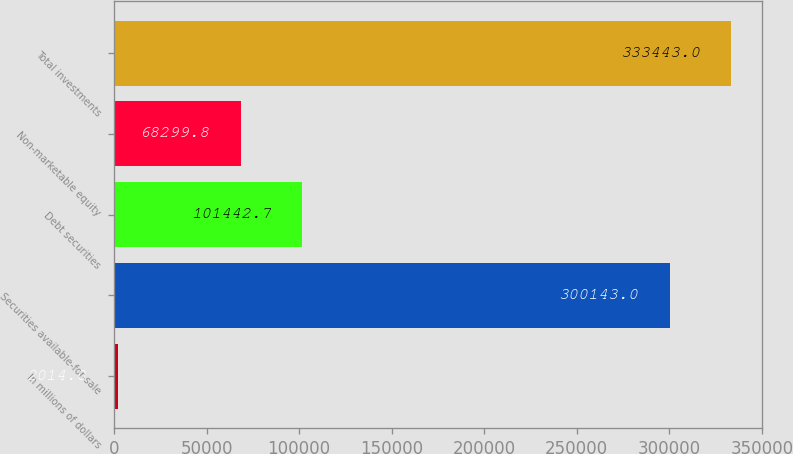<chart> <loc_0><loc_0><loc_500><loc_500><bar_chart><fcel>In millions of dollars<fcel>Securities available-for-sale<fcel>Debt securities<fcel>Non-marketable equity<fcel>Total investments<nl><fcel>2014<fcel>300143<fcel>101443<fcel>68299.8<fcel>333443<nl></chart> 